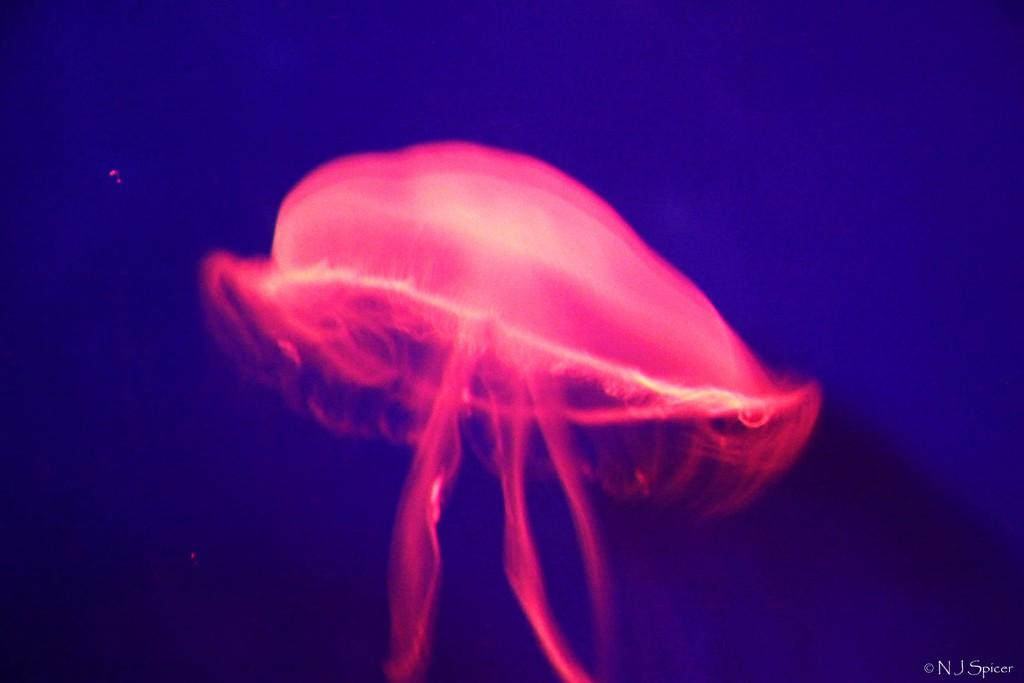What is the main subject in the foreground of the image? There is a jellyfish in the foreground of the image. What color is the background of the image? The background of the image is blue. Is there any text present in the image? Yes, there is text at the bottom side of the image. What type of education is the jellyfish pursuing in the image? There is no indication in the image that the jellyfish is pursuing any type of education. 